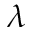<formula> <loc_0><loc_0><loc_500><loc_500>\lambda</formula> 